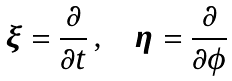Convert formula to latex. <formula><loc_0><loc_0><loc_500><loc_500>\boldsymbol \xi = \frac { \partial } { \partial t } \, , \quad \boldsymbol \eta = \frac { \partial } { \partial \phi }</formula> 